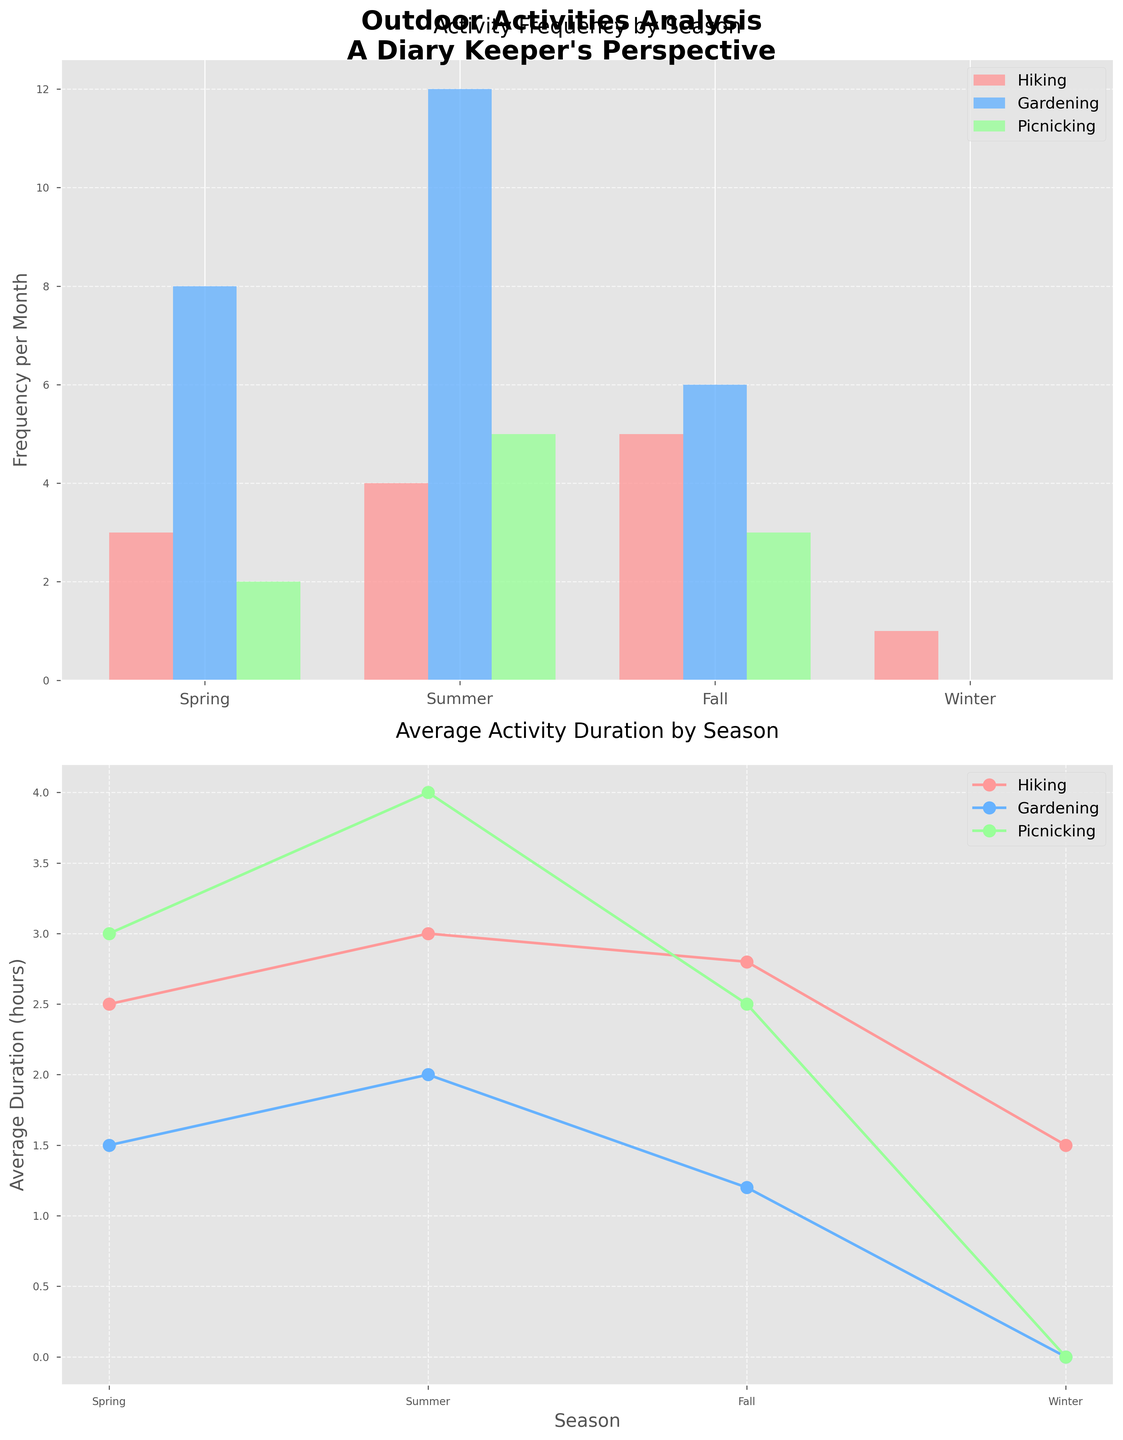Which activity occurs most frequently in the summer? According to the bar chart for activity frequency by season, in summer, gardening has the highest frequency bar compared to hiking and picnicking.
Answer: Gardening In which season does hiking have the highest average duration? The line plot for average activity duration by season shows the highest point for hiking during the summer season.
Answer: Summer What is the total frequency of all activities combined in the fall? For the fall season, the frequencies are: hiking (5), gardening (6), and picnicking (3). Summing these values: 5 + 6 + 3 = 14.
Answer: 14 Which activity shows the largest drop in frequency from summer to winter? By comparing the frequency bars from summer to winter, gardening drops from 12 to 0, which is greater than the drops for hiking (4 to 1) and picnicking (5 to 0).
Answer: Gardening How does the average duration of picnicking in summer compare to that in the spring? The line plot for average activity duration by season shows the picnicking duration in summer is 4 hours and in spring is 3 hours. Since 4 is greater than 3, picnicking in summer has a higher duration.
Answer: Summer duration is higher Which activity has zero frequency in the winter? The bar chart for activity frequency by season shows zero bars for both gardening and picnicking in winter.
Answer: Gardening and Picnicking Which season has the lowest average duration for hiking? The line plot for average activity duration by season shows the lowest point for hiking during the winter season.
Answer: Winter 